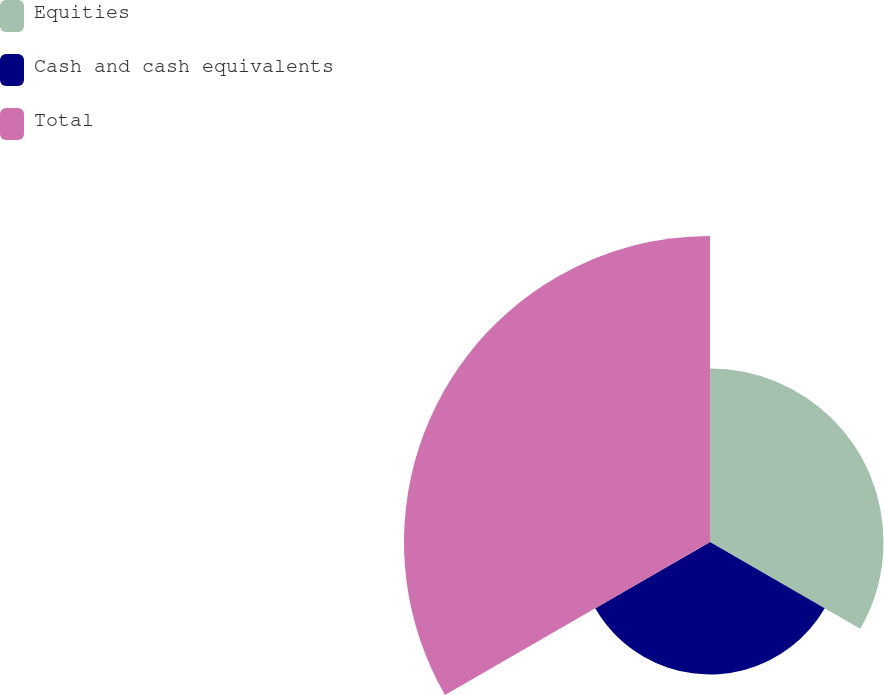<chart> <loc_0><loc_0><loc_500><loc_500><pie_chart><fcel>Equities<fcel>Cash and cash equivalents<fcel>Total<nl><fcel>28.35%<fcel>21.65%<fcel>50.0%<nl></chart> 